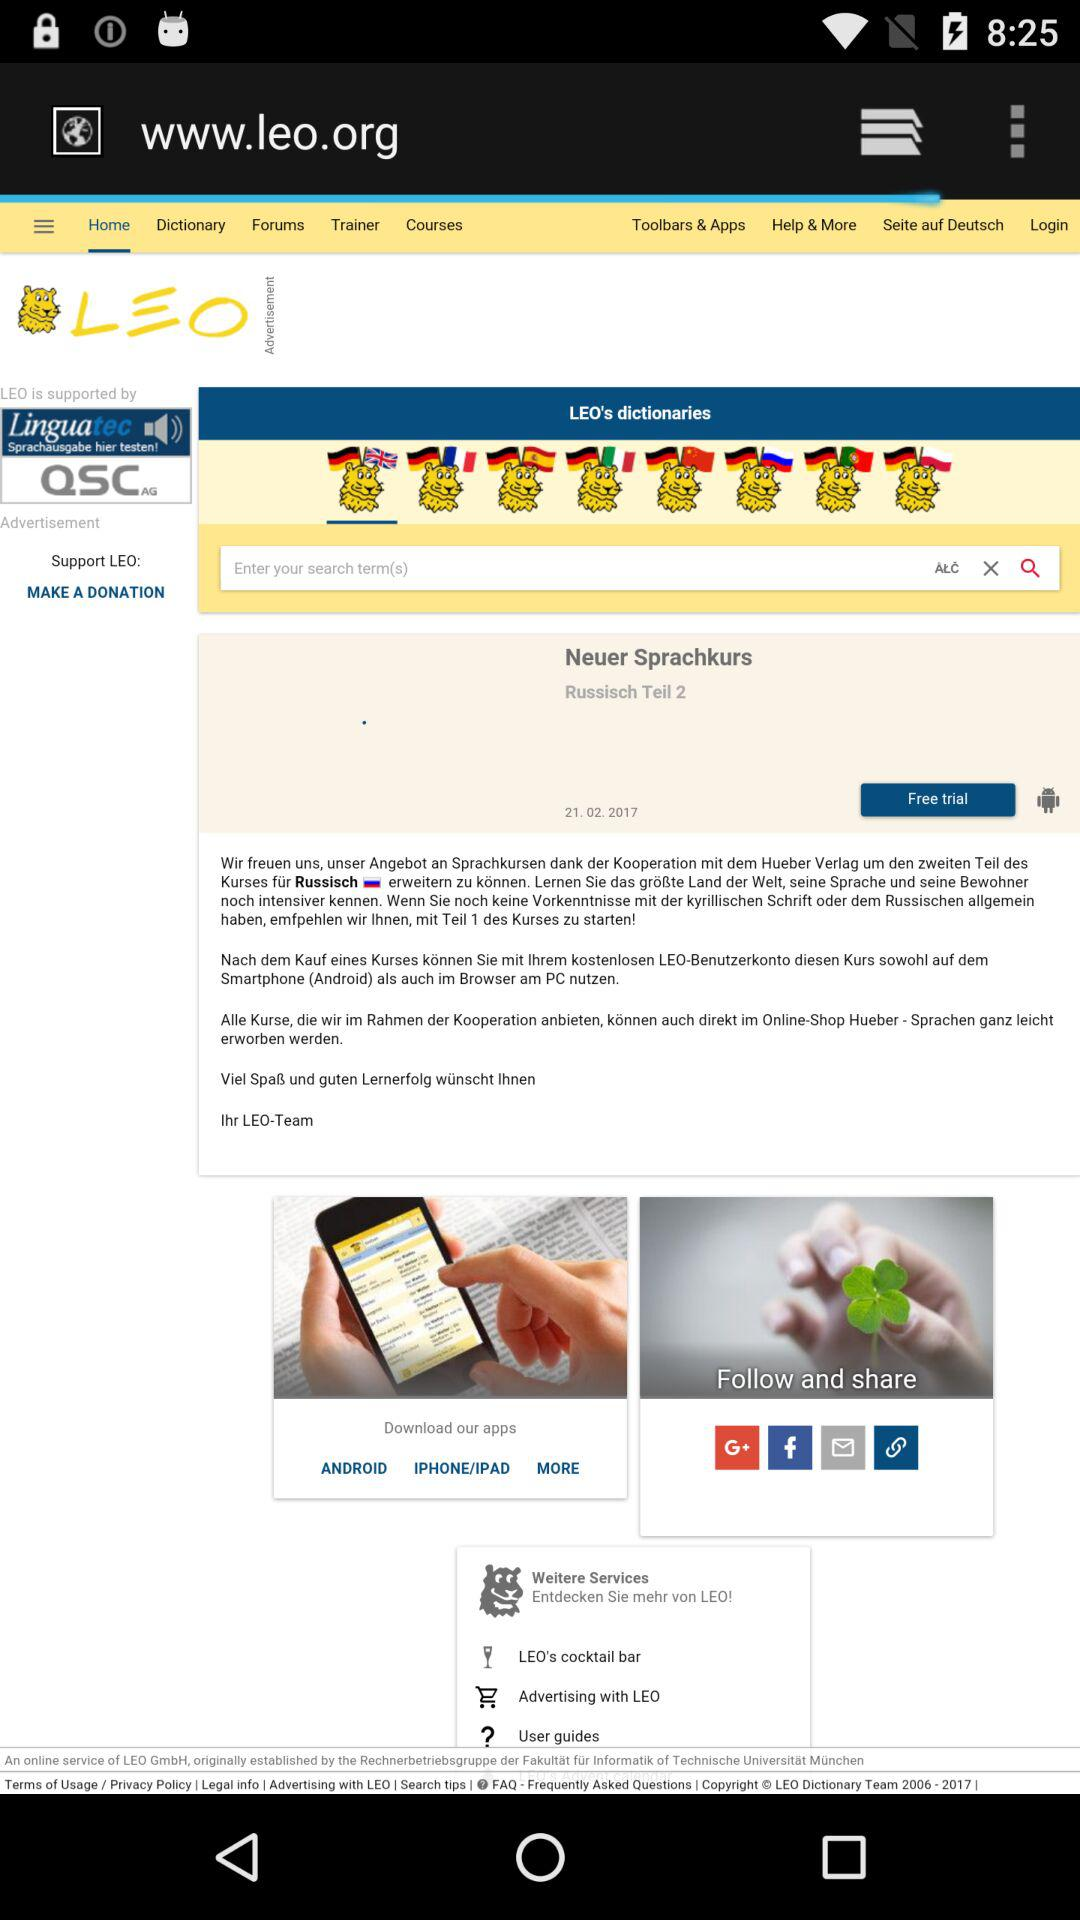What is the shown date? The shown date is February 21, 2017. 